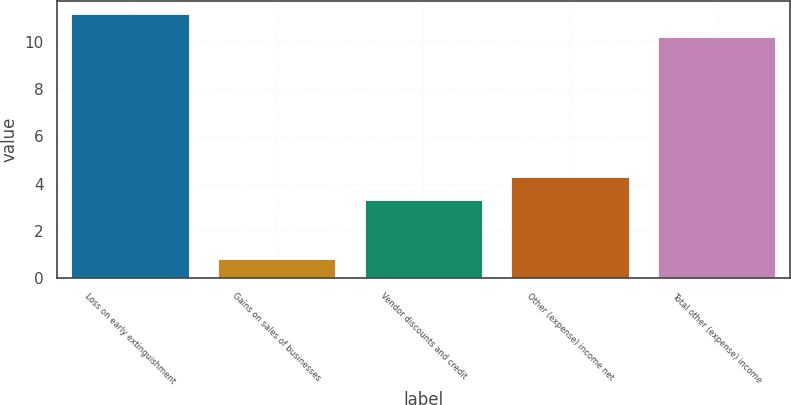Convert chart. <chart><loc_0><loc_0><loc_500><loc_500><bar_chart><fcel>Loss on early extinguishment<fcel>Gains on sales of businesses<fcel>Vendor discounts and credit<fcel>Other (expense) income net<fcel>Total other (expense) income<nl><fcel>11.16<fcel>0.8<fcel>3.3<fcel>4.26<fcel>10.2<nl></chart> 